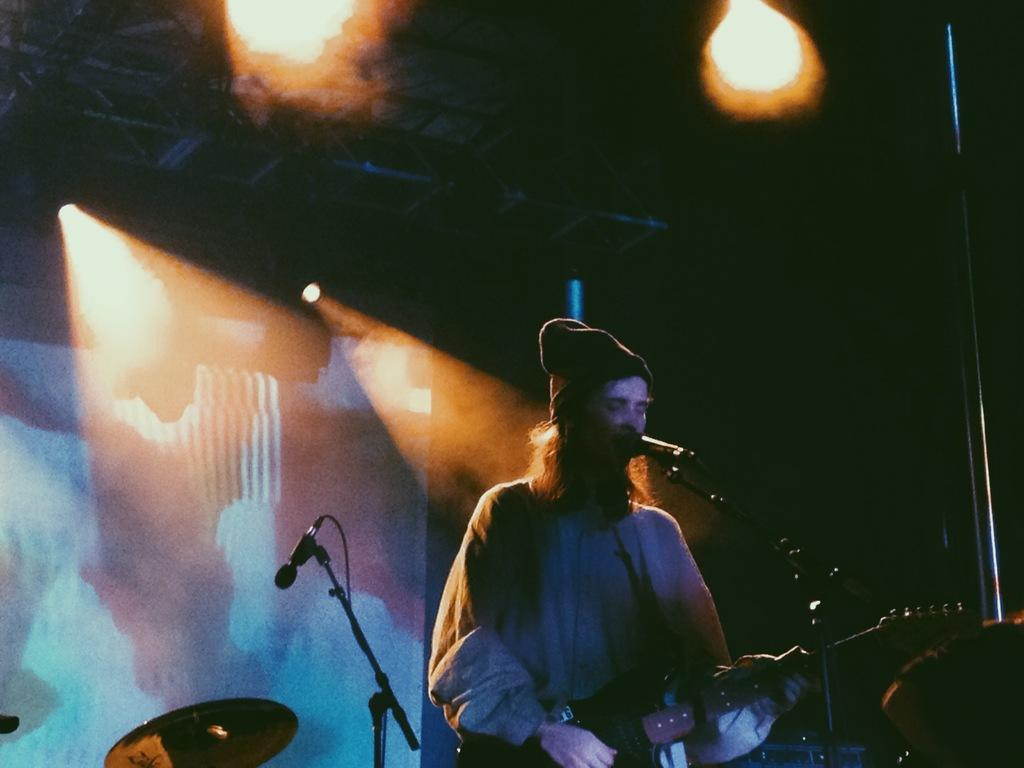What is the person in the image doing? The person is playing a guitar in the image. What object is present that might be used for amplifying the person's voice? There is a microphone in the image. What can be seen in the background of the image? There is a screen in the background of the image. What type of lighting is visible in the image? There are lights visible at the top of the image. How many lizards are crawling on the guitar in the image? There are no lizards present in the image; the person is playing a guitar without any lizards. 